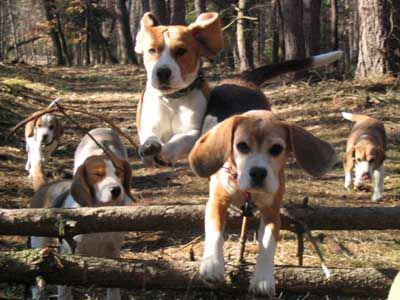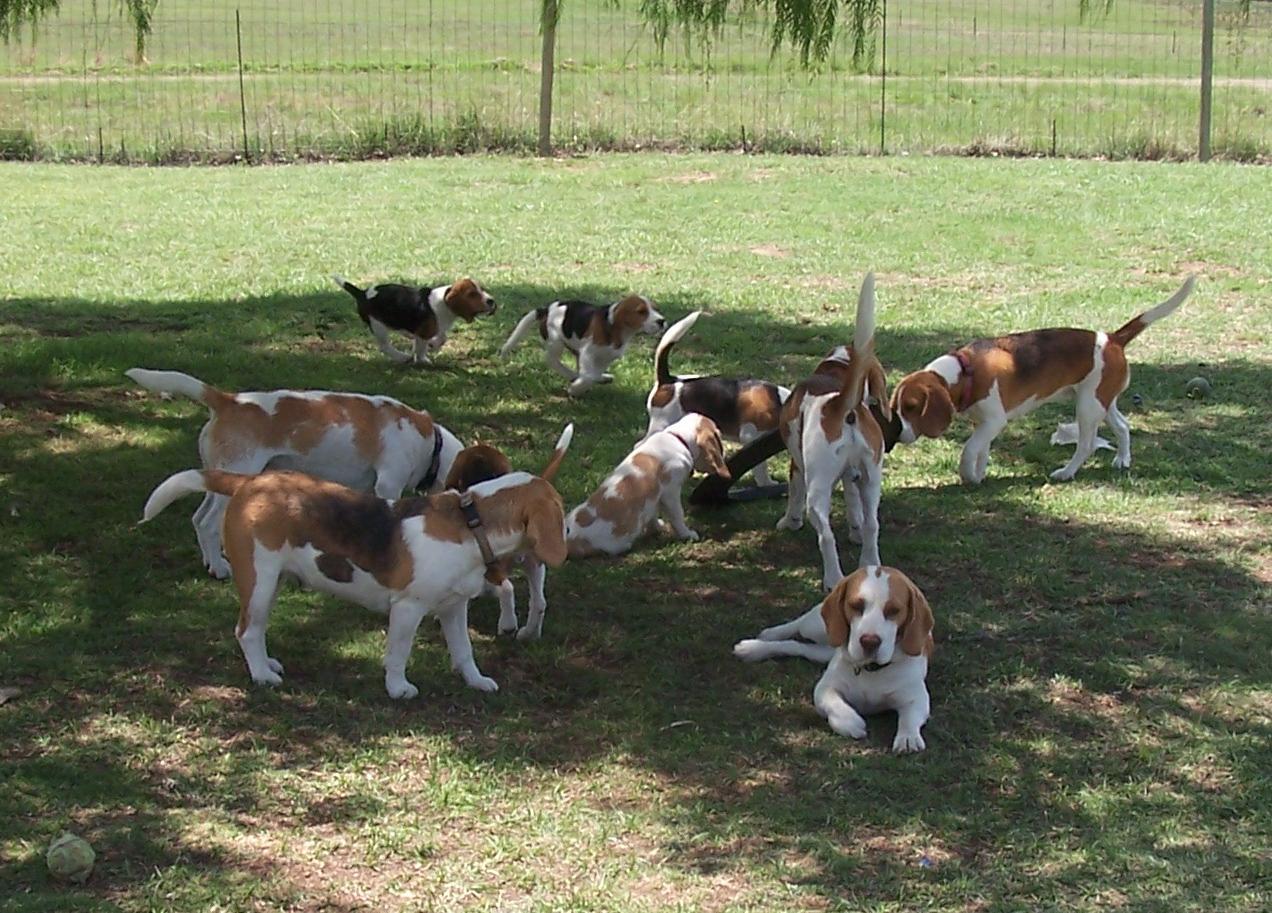The first image is the image on the left, the second image is the image on the right. Examine the images to the left and right. Is the description "There are people near some of the dogs." accurate? Answer yes or no. No. The first image is the image on the left, the second image is the image on the right. Assess this claim about the two images: "One image contains exactly two animals, at least one of them a beagle.". Correct or not? Answer yes or no. No. 